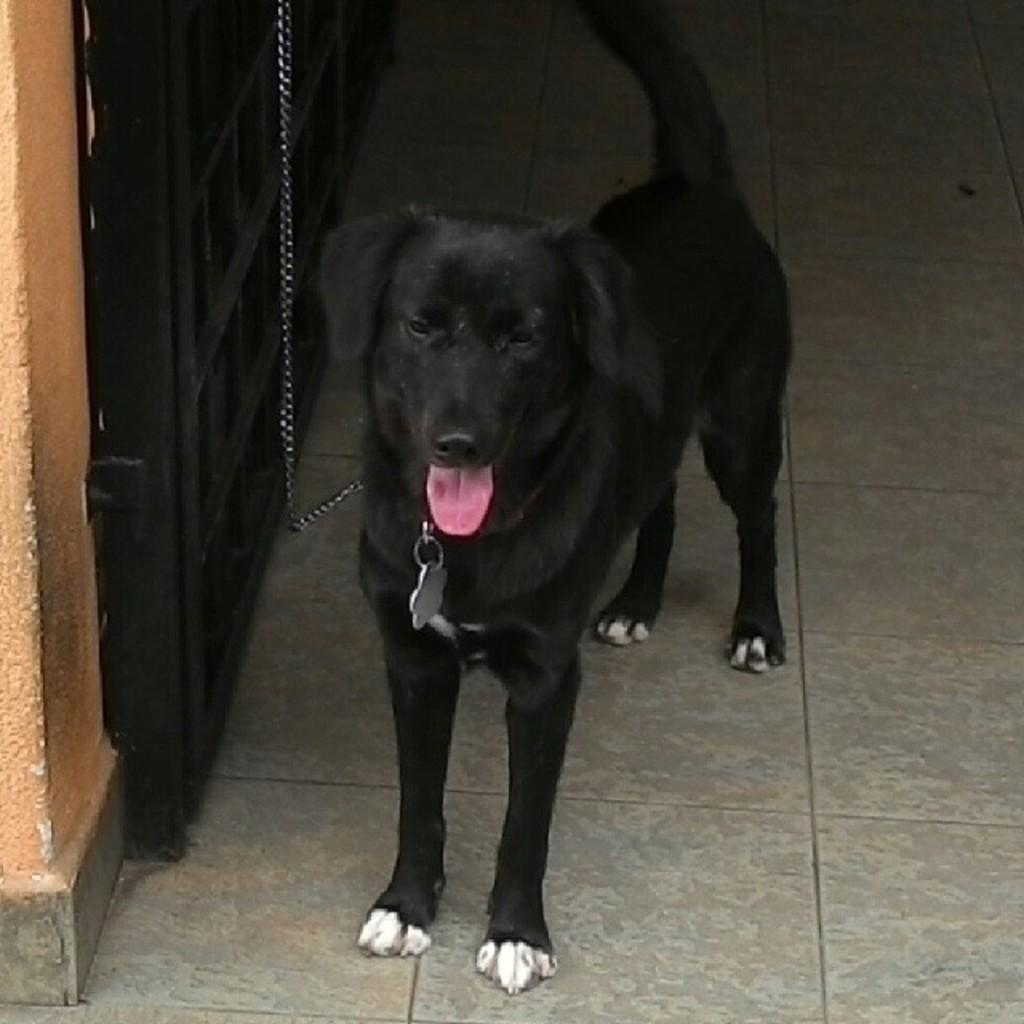What is the main subject in the image? There is a black object standing in the image. What is the black object tied to? The black object is tied to a chain. What can be seen on the left side of the image? There is a black gate on the left side of the image. What type of voice can be heard coming from the black object in the image? There is no voice coming from the black object in the image, as it is an inanimate object. 